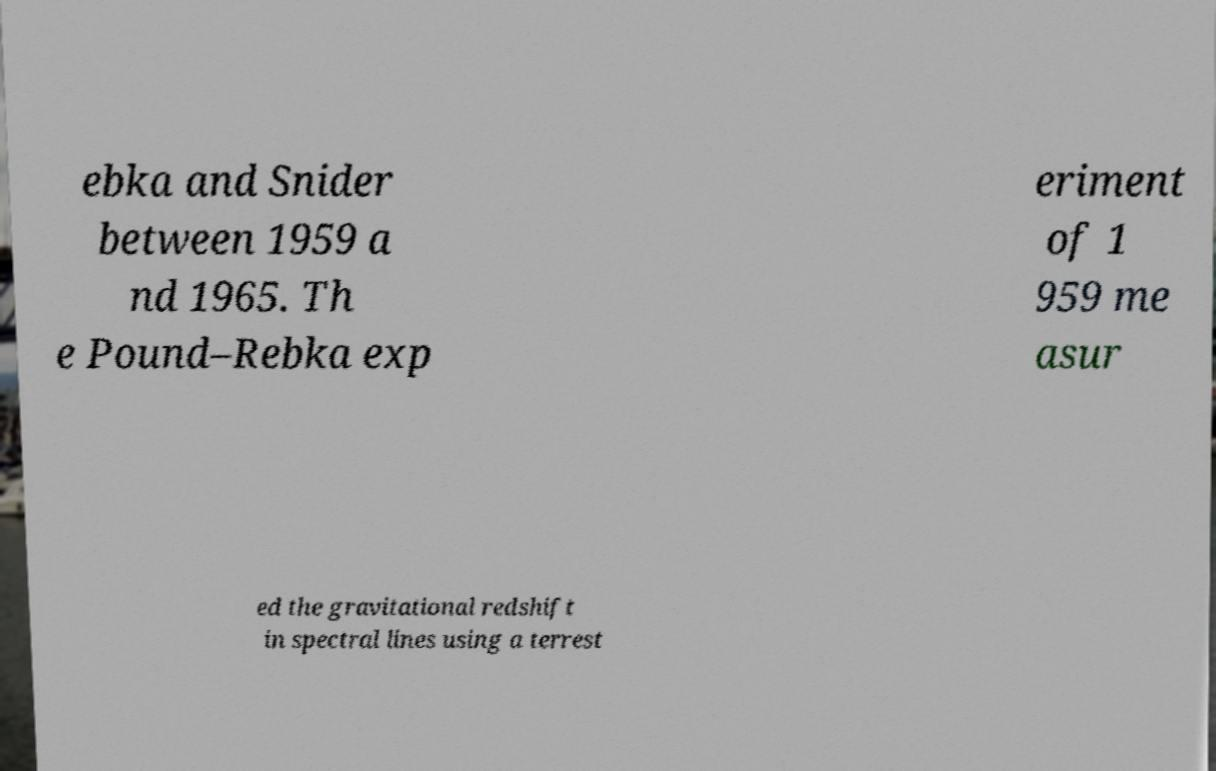Could you assist in decoding the text presented in this image and type it out clearly? ebka and Snider between 1959 a nd 1965. Th e Pound–Rebka exp eriment of 1 959 me asur ed the gravitational redshift in spectral lines using a terrest 